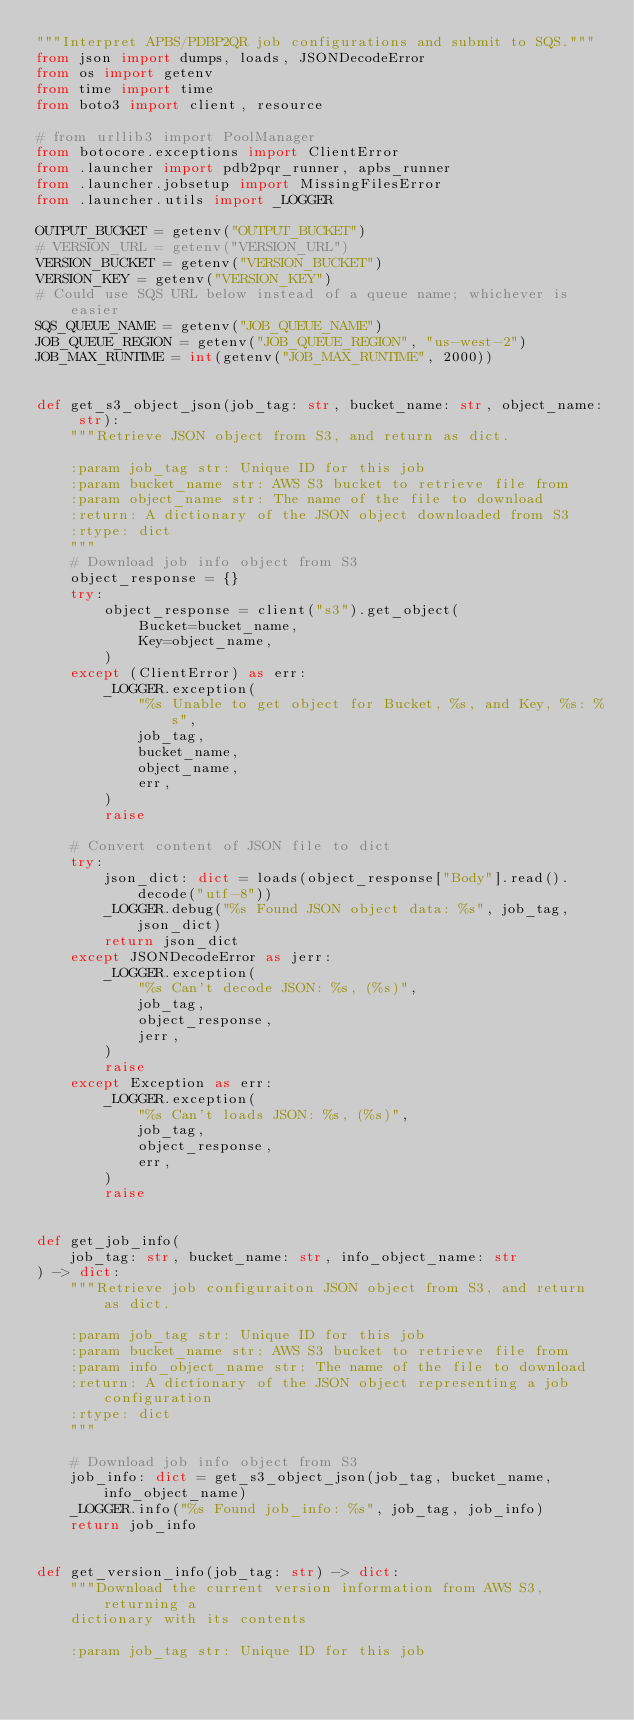Convert code to text. <code><loc_0><loc_0><loc_500><loc_500><_Python_>"""Interpret APBS/PDBP2QR job configurations and submit to SQS."""
from json import dumps, loads, JSONDecodeError
from os import getenv
from time import time
from boto3 import client, resource

# from urllib3 import PoolManager
from botocore.exceptions import ClientError
from .launcher import pdb2pqr_runner, apbs_runner
from .launcher.jobsetup import MissingFilesError
from .launcher.utils import _LOGGER

OUTPUT_BUCKET = getenv("OUTPUT_BUCKET")
# VERSION_URL = getenv("VERSION_URL")
VERSION_BUCKET = getenv("VERSION_BUCKET")
VERSION_KEY = getenv("VERSION_KEY")
# Could use SQS URL below instead of a queue name; whichever is easier
SQS_QUEUE_NAME = getenv("JOB_QUEUE_NAME")
JOB_QUEUE_REGION = getenv("JOB_QUEUE_REGION", "us-west-2")
JOB_MAX_RUNTIME = int(getenv("JOB_MAX_RUNTIME", 2000))


def get_s3_object_json(job_tag: str, bucket_name: str, object_name: str):
    """Retrieve JSON object from S3, and return as dict.

    :param job_tag str: Unique ID for this job
    :param bucket_name str: AWS S3 bucket to retrieve file from
    :param object_name str: The name of the file to download
    :return: A dictionary of the JSON object downloaded from S3
    :rtype: dict
    """
    # Download job info object from S3
    object_response = {}
    try:
        object_response = client("s3").get_object(
            Bucket=bucket_name,
            Key=object_name,
        )
    except (ClientError) as err:
        _LOGGER.exception(
            "%s Unable to get object for Bucket, %s, and Key, %s: %s",
            job_tag,
            bucket_name,
            object_name,
            err,
        )
        raise

    # Convert content of JSON file to dict
    try:
        json_dict: dict = loads(object_response["Body"].read().decode("utf-8"))
        _LOGGER.debug("%s Found JSON object data: %s", job_tag, json_dict)
        return json_dict
    except JSONDecodeError as jerr:
        _LOGGER.exception(
            "%s Can't decode JSON: %s, (%s)",
            job_tag,
            object_response,
            jerr,
        )
        raise
    except Exception as err:
        _LOGGER.exception(
            "%s Can't loads JSON: %s, (%s)",
            job_tag,
            object_response,
            err,
        )
        raise


def get_job_info(
    job_tag: str, bucket_name: str, info_object_name: str
) -> dict:
    """Retrieve job configuraiton JSON object from S3, and return as dict.

    :param job_tag str: Unique ID for this job
    :param bucket_name str: AWS S3 bucket to retrieve file from
    :param info_object_name str: The name of the file to download
    :return: A dictionary of the JSON object representing a job configuration
    :rtype: dict
    """

    # Download job info object from S3
    job_info: dict = get_s3_object_json(job_tag, bucket_name, info_object_name)
    _LOGGER.info("%s Found job_info: %s", job_tag, job_info)
    return job_info


def get_version_info(job_tag: str) -> dict:
    """Download the current version information from AWS S3, returning a
    dictionary with its contents

    :param job_tag str: Unique ID for this job</code> 